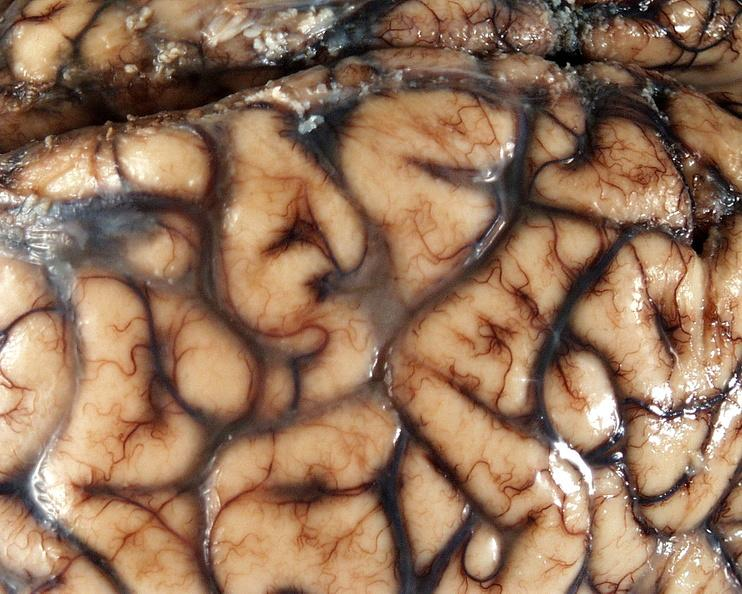does this image show brain, cryptococcal meningitis?
Answer the question using a single word or phrase. Yes 